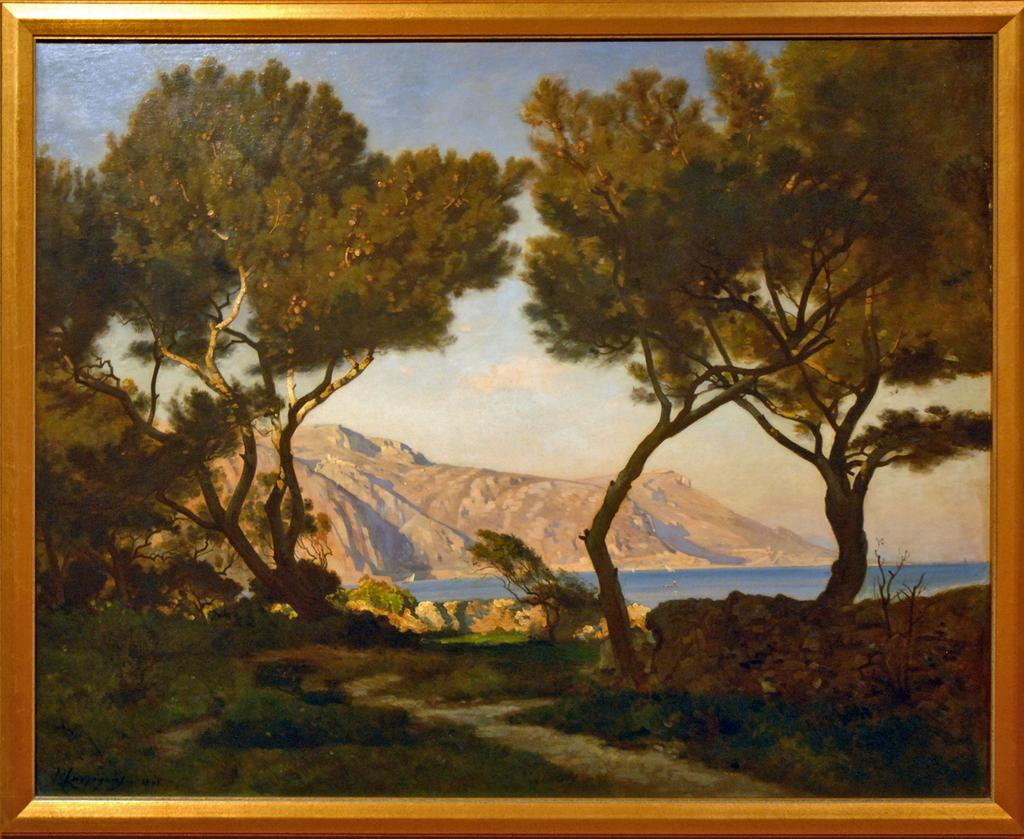What is the main subject of the image? The main subject of the image is a frame. What elements can be seen within the frame? The frame contains trees, mountains, a river, and a sky. Can you describe the landscape depicted in the image? The landscape includes trees, mountains, a river, and a sky. How many pickles are hanging from the trees in the image? There are no pickles present in the image; it features a landscape with trees, mountains, a river, and a sky. 